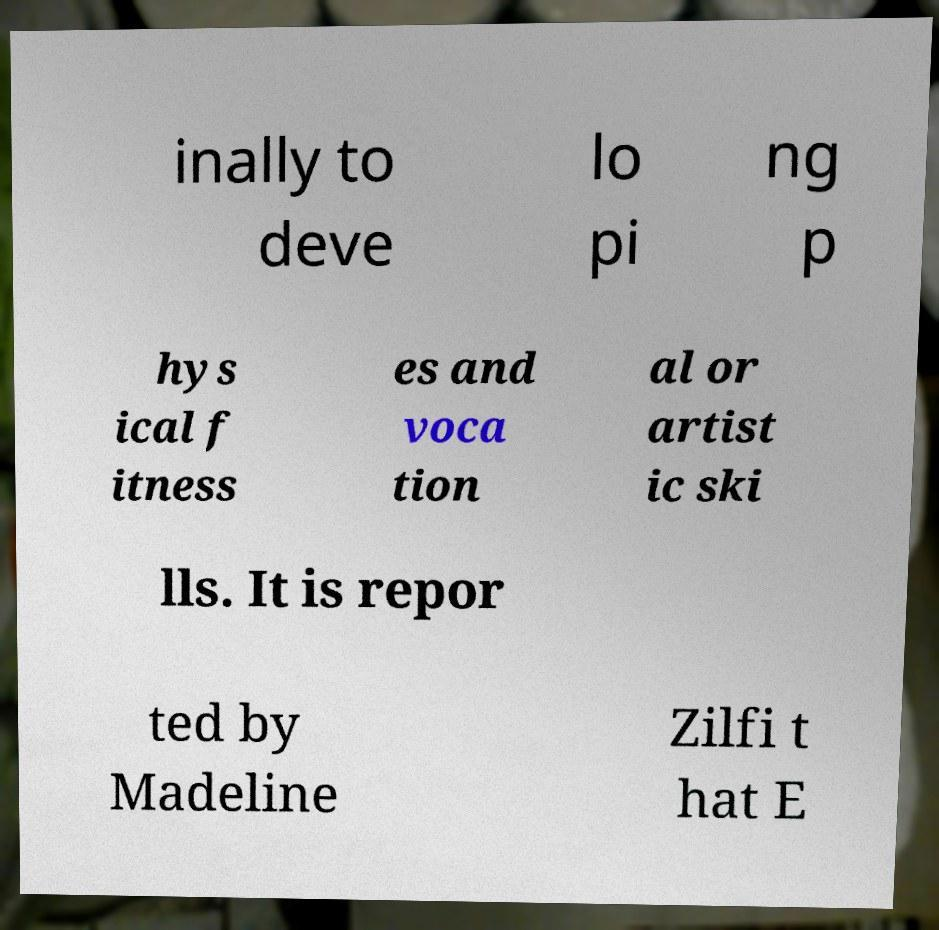Can you accurately transcribe the text from the provided image for me? inally to deve lo pi ng p hys ical f itness es and voca tion al or artist ic ski lls. It is repor ted by Madeline Zilfi t hat E 